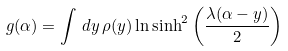Convert formula to latex. <formula><loc_0><loc_0><loc_500><loc_500>g ( \alpha ) = \int \, d y \, \rho ( y ) \ln \sinh ^ { 2 } \left ( \frac { \lambda ( \alpha - y ) } { 2 } \right )</formula> 